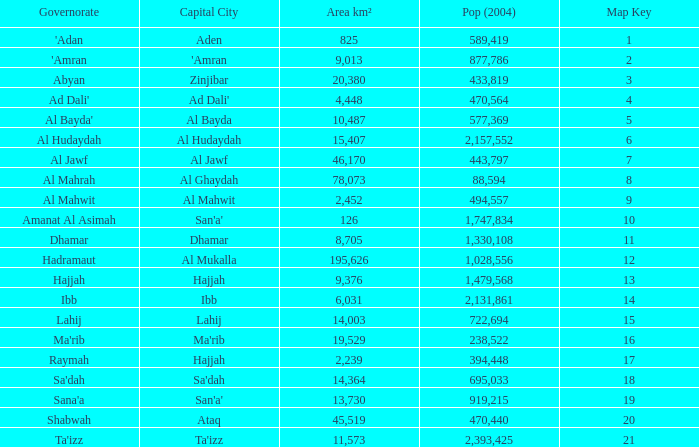How many map keys have a 2004 population under 433,819, a capital city called hajjah, and an area smaller than 9,376 km²? 17.0. 